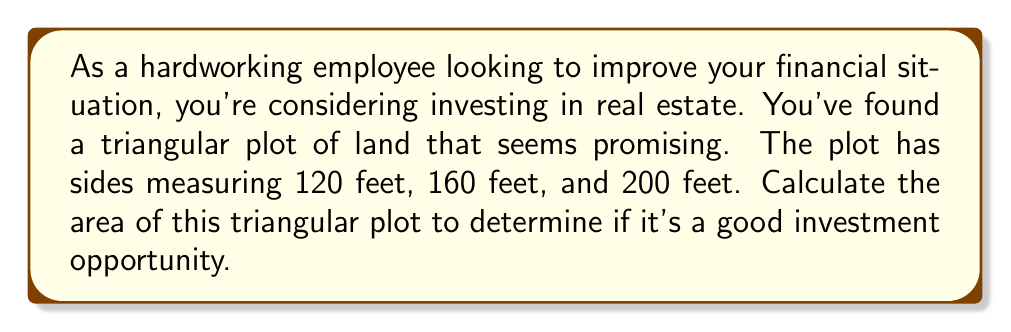What is the answer to this math problem? To calculate the area of a triangle when we know all three sides, we can use Heron's formula. Let's break this down step-by-step:

1) First, recall Heron's formula:
   $$A = \sqrt{s(s-a)(s-b)(s-c)}$$
   where $A$ is the area, $a$, $b$, and $c$ are the lengths of the sides, and $s$ is the semi-perimeter.

2) We know that $a = 120$ ft, $b = 160$ ft, and $c = 200$ ft.

3) Calculate the semi-perimeter $s$:
   $$s = \frac{a + b + c}{2} = \frac{120 + 160 + 200}{2} = \frac{480}{2} = 240$$ ft

4) Now, let's substitute these values into Heron's formula:
   $$A = \sqrt{240(240-120)(240-160)(240-200)}$$

5) Simplify inside the parentheses:
   $$A = \sqrt{240 \cdot 120 \cdot 80 \cdot 40}$$

6) Multiply the numbers inside the square root:
   $$A = \sqrt{92,160,000}$$

7) Calculate the square root:
   $$A = 9,600$$ sq ft

Therefore, the area of the triangular plot is 9,600 square feet.

[asy]
unitsize(0.02feet);
pair A = (0,0), B = (200,0), C = (60,80*sqrt(3));
draw(A--B--C--cycle);
label("200 ft", (100,-10), S);
label("160 ft", (130,40*sqrt(3)), NE);
label("120 ft", (30,40*sqrt(3)), NW);
label("A", A, SW);
label("B", B, SE);
label("C", C, N);
[/asy]
Answer: The area of the triangular plot is 9,600 square feet. 